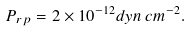Convert formula to latex. <formula><loc_0><loc_0><loc_500><loc_500>P _ { r p } = 2 \times 1 0 ^ { - 1 2 } d y n \, c m ^ { - 2 } .</formula> 